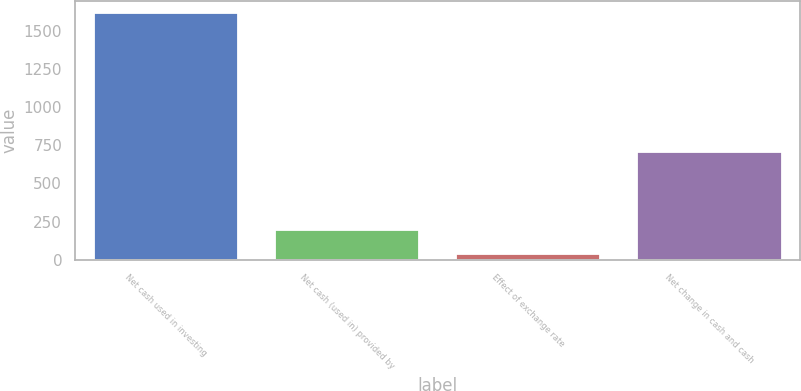<chart> <loc_0><loc_0><loc_500><loc_500><bar_chart><fcel>Net cash used in investing<fcel>Net cash (used in) provided by<fcel>Effect of exchange rate<fcel>Net change in cash and cash<nl><fcel>1612.7<fcel>191.87<fcel>34<fcel>702.6<nl></chart> 